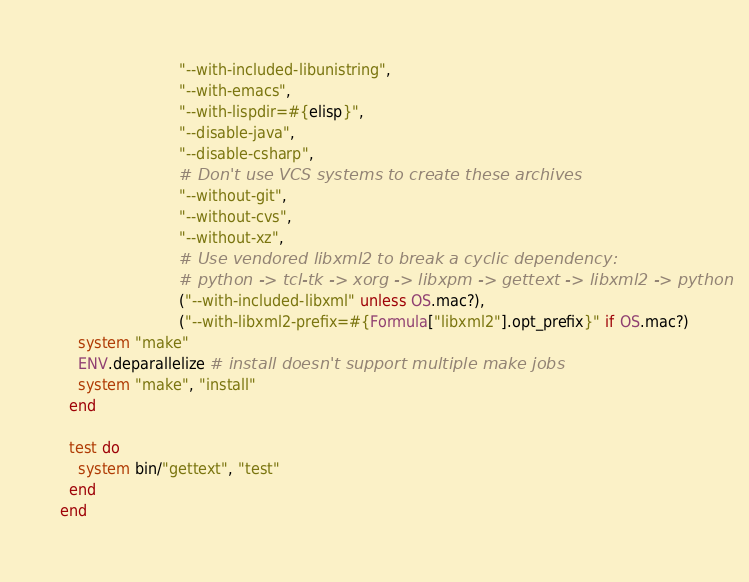Convert code to text. <code><loc_0><loc_0><loc_500><loc_500><_Ruby_>                          "--with-included-libunistring",
                          "--with-emacs",
                          "--with-lispdir=#{elisp}",
                          "--disable-java",
                          "--disable-csharp",
                          # Don't use VCS systems to create these archives
                          "--without-git",
                          "--without-cvs",
                          "--without-xz",
                          # Use vendored libxml2 to break a cyclic dependency:
                          # python -> tcl-tk -> xorg -> libxpm -> gettext -> libxml2 -> python
                          ("--with-included-libxml" unless OS.mac?),
                          ("--with-libxml2-prefix=#{Formula["libxml2"].opt_prefix}" if OS.mac?)
    system "make"
    ENV.deparallelize # install doesn't support multiple make jobs
    system "make", "install"
  end

  test do
    system bin/"gettext", "test"
  end
end
</code> 